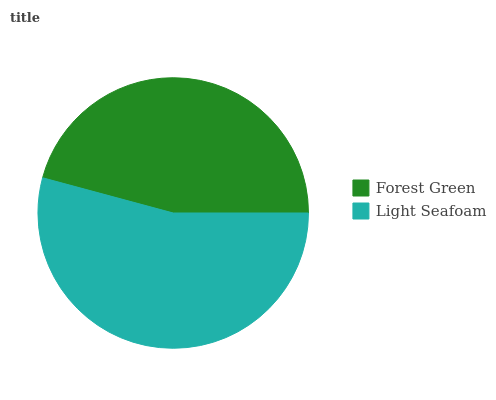Is Forest Green the minimum?
Answer yes or no. Yes. Is Light Seafoam the maximum?
Answer yes or no. Yes. Is Light Seafoam the minimum?
Answer yes or no. No. Is Light Seafoam greater than Forest Green?
Answer yes or no. Yes. Is Forest Green less than Light Seafoam?
Answer yes or no. Yes. Is Forest Green greater than Light Seafoam?
Answer yes or no. No. Is Light Seafoam less than Forest Green?
Answer yes or no. No. Is Light Seafoam the high median?
Answer yes or no. Yes. Is Forest Green the low median?
Answer yes or no. Yes. Is Forest Green the high median?
Answer yes or no. No. Is Light Seafoam the low median?
Answer yes or no. No. 